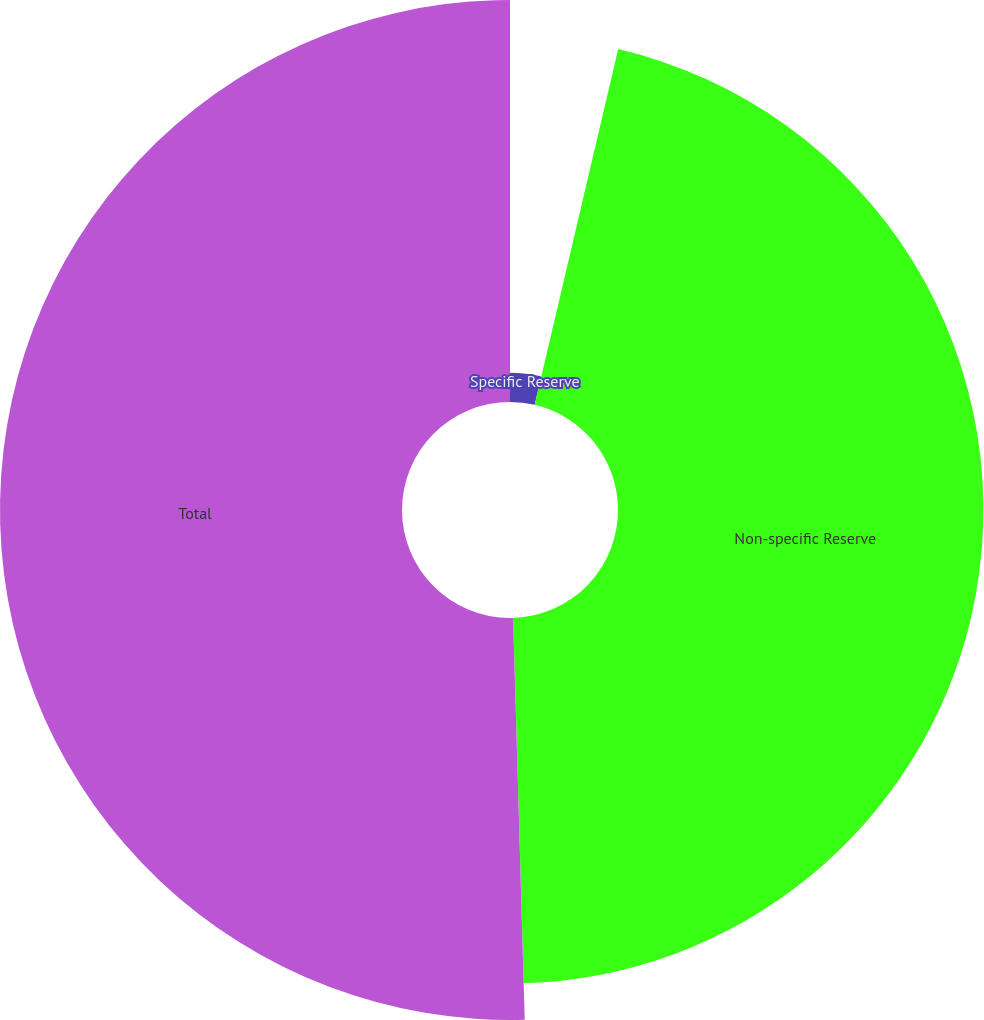Convert chart to OTSL. <chart><loc_0><loc_0><loc_500><loc_500><pie_chart><fcel>Specific Reserve<fcel>Non-specific Reserve<fcel>Total<nl><fcel>3.67%<fcel>45.87%<fcel>50.46%<nl></chart> 